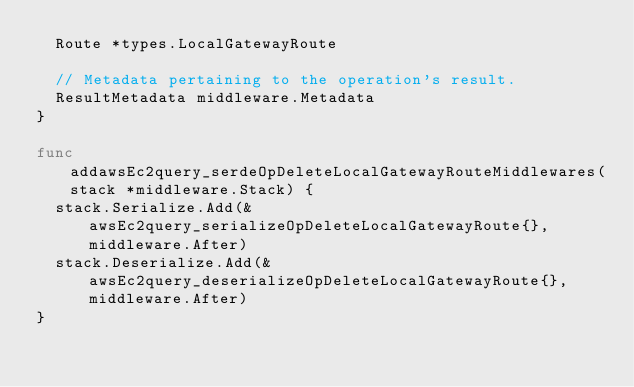Convert code to text. <code><loc_0><loc_0><loc_500><loc_500><_Go_>	Route *types.LocalGatewayRoute

	// Metadata pertaining to the operation's result.
	ResultMetadata middleware.Metadata
}

func addawsEc2query_serdeOpDeleteLocalGatewayRouteMiddlewares(stack *middleware.Stack) {
	stack.Serialize.Add(&awsEc2query_serializeOpDeleteLocalGatewayRoute{}, middleware.After)
	stack.Deserialize.Add(&awsEc2query_deserializeOpDeleteLocalGatewayRoute{}, middleware.After)
}
</code> 